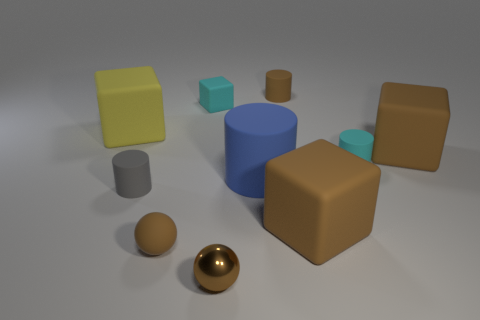Are there any tiny brown things of the same shape as the gray matte object?
Keep it short and to the point. Yes. What number of small cyan blocks are there?
Ensure brevity in your answer.  1. What is the shape of the small metal thing?
Keep it short and to the point. Sphere. How many yellow cubes are the same size as the blue cylinder?
Ensure brevity in your answer.  1. Is the small gray rubber thing the same shape as the large yellow object?
Offer a very short reply. No. There is a block left of the tiny cyan matte thing to the left of the small cyan cylinder; what color is it?
Keep it short and to the point. Yellow. There is a brown thing that is behind the small brown shiny sphere and to the left of the large blue cylinder; what size is it?
Your answer should be very brief. Small. Are there any other things of the same color as the shiny thing?
Provide a short and direct response. Yes. There is a gray thing that is the same material as the large blue cylinder; what is its shape?
Your answer should be compact. Cylinder. There is a blue matte object; is its shape the same as the small cyan rubber thing that is on the right side of the brown metallic ball?
Your response must be concise. Yes. 